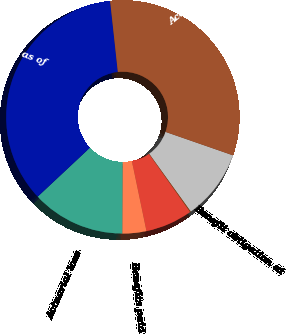Convert chart. <chart><loc_0><loc_0><loc_500><loc_500><pie_chart><fcel>Benefit obligation at<fcel>Service cost<fcel>Interest cost<fcel>Benefits paid<fcel>Actuarial loss<fcel>Benefit obligation as of<fcel>Accumulated Benefit Obligation<nl><fcel>9.75%<fcel>0.12%<fcel>6.54%<fcel>3.33%<fcel>12.96%<fcel>35.25%<fcel>32.04%<nl></chart> 